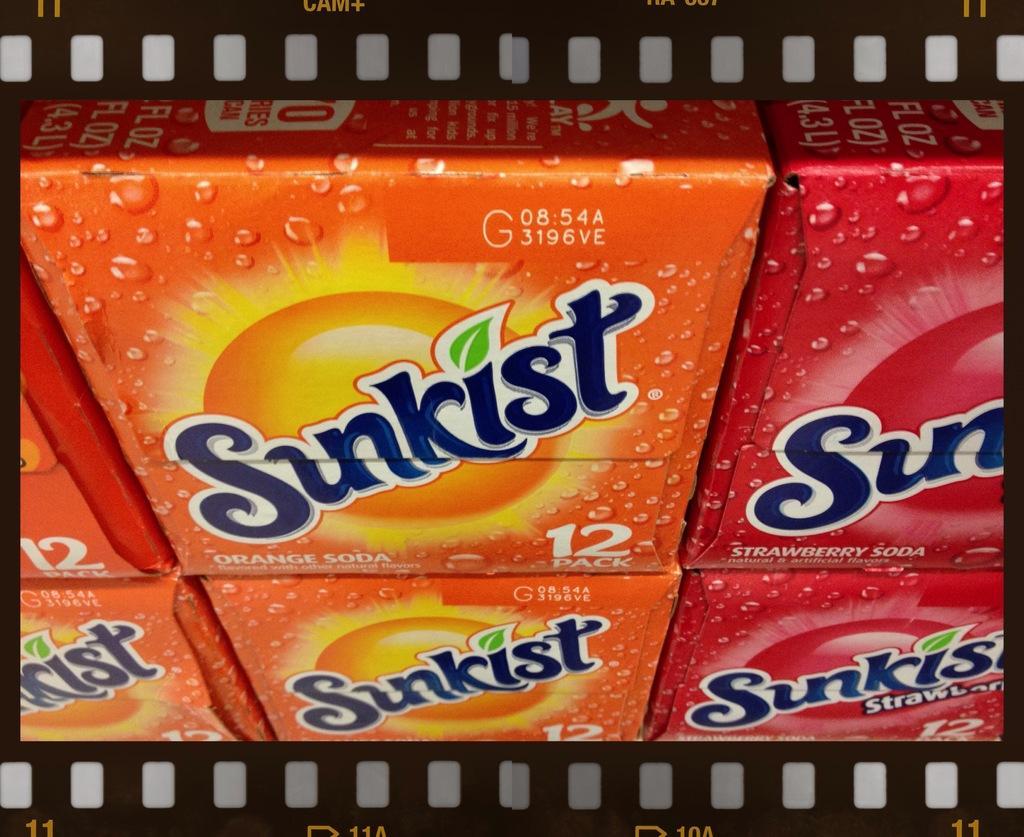Please provide a concise description of this image. In this image there are soda packets. There are two different flavors in it. In the center there is an orange flavor. On the right we can see strawberry flavor. 